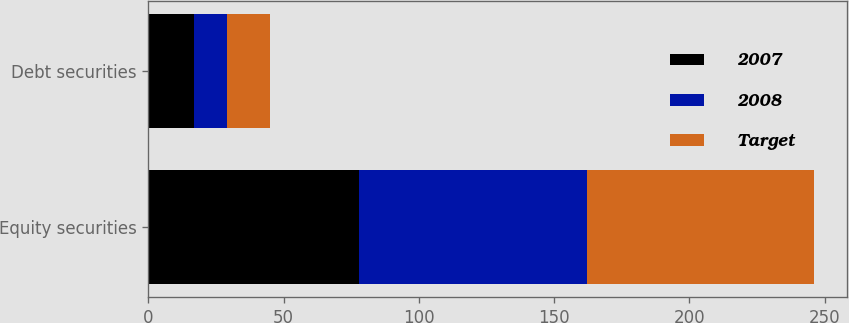Convert chart to OTSL. <chart><loc_0><loc_0><loc_500><loc_500><stacked_bar_chart><ecel><fcel>Equity securities<fcel>Debt securities<nl><fcel>2007<fcel>78<fcel>17<nl><fcel>2008<fcel>84<fcel>12<nl><fcel>Target<fcel>84<fcel>16<nl></chart> 